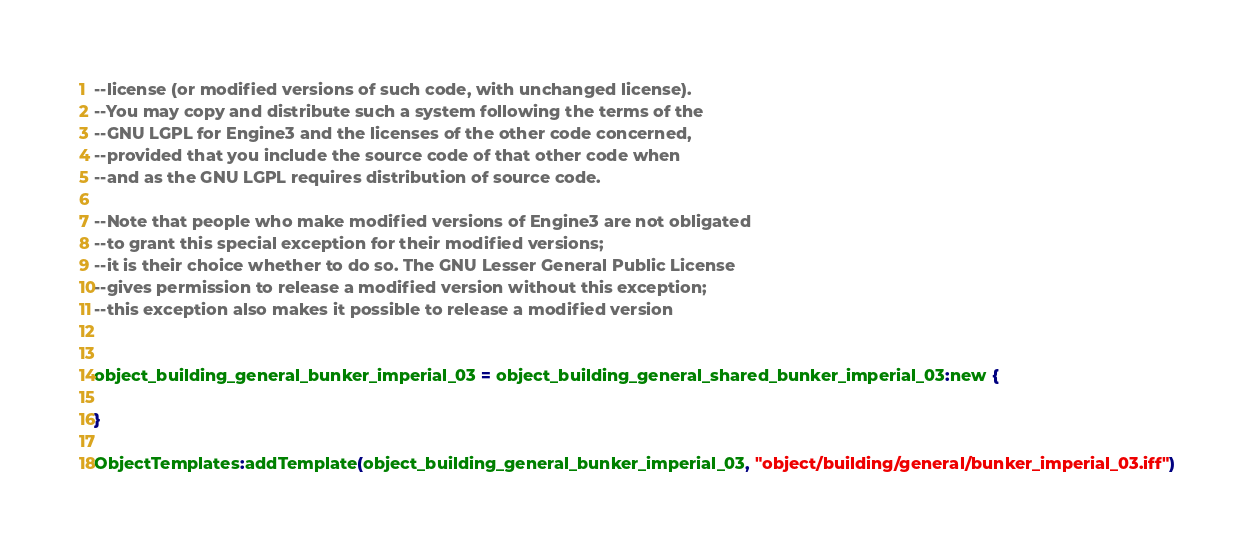<code> <loc_0><loc_0><loc_500><loc_500><_Lua_>--license (or modified versions of such code, with unchanged license). 
--You may copy and distribute such a system following the terms of the 
--GNU LGPL for Engine3 and the licenses of the other code concerned, 
--provided that you include the source code of that other code when 
--and as the GNU LGPL requires distribution of source code.

--Note that people who make modified versions of Engine3 are not obligated 
--to grant this special exception for their modified versions; 
--it is their choice whether to do so. The GNU Lesser General Public License 
--gives permission to release a modified version without this exception; 
--this exception also makes it possible to release a modified version 


object_building_general_bunker_imperial_03 = object_building_general_shared_bunker_imperial_03:new {

}

ObjectTemplates:addTemplate(object_building_general_bunker_imperial_03, "object/building/general/bunker_imperial_03.iff")
</code> 